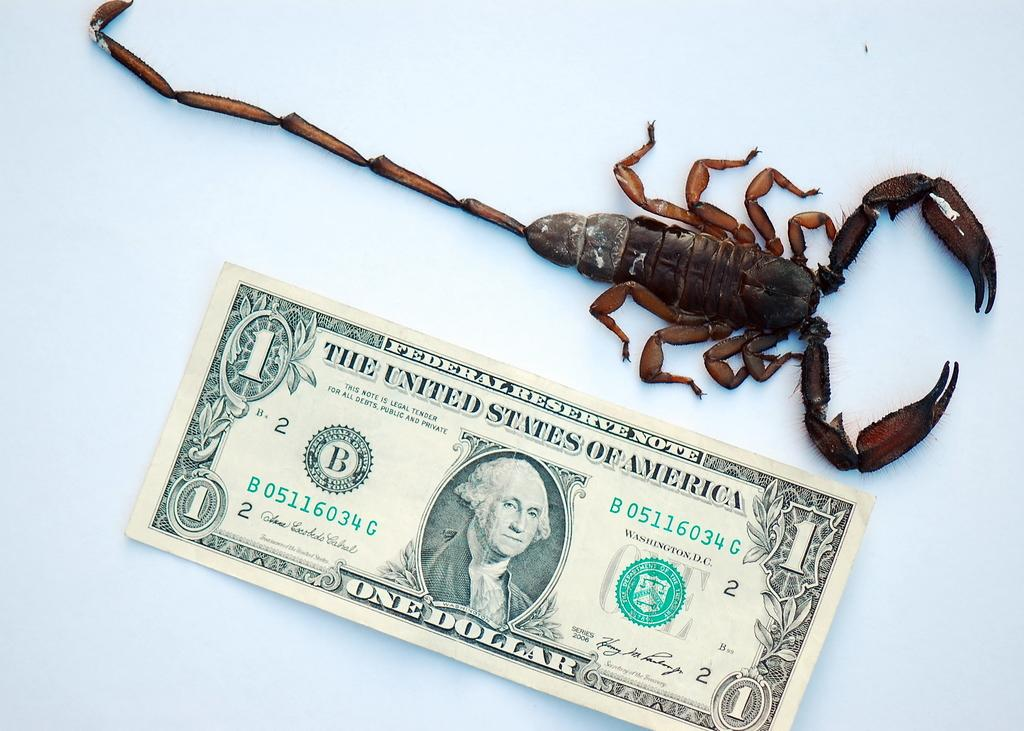What is the main subject in the middle of the image? There is a paper with pictures and text in the middle of the image, as well as a reptile. Can you describe the paper in the image? The paper has pictures and text on it. What is the color of the background in the image? The background of the image is white. What type of mountain can be seen in the background of the image? There is no mountain present in the image; the background is white. How many rooms are visible in the image? There is no room present in the image; it features a paper with pictures and text, a reptile, and a white background. 